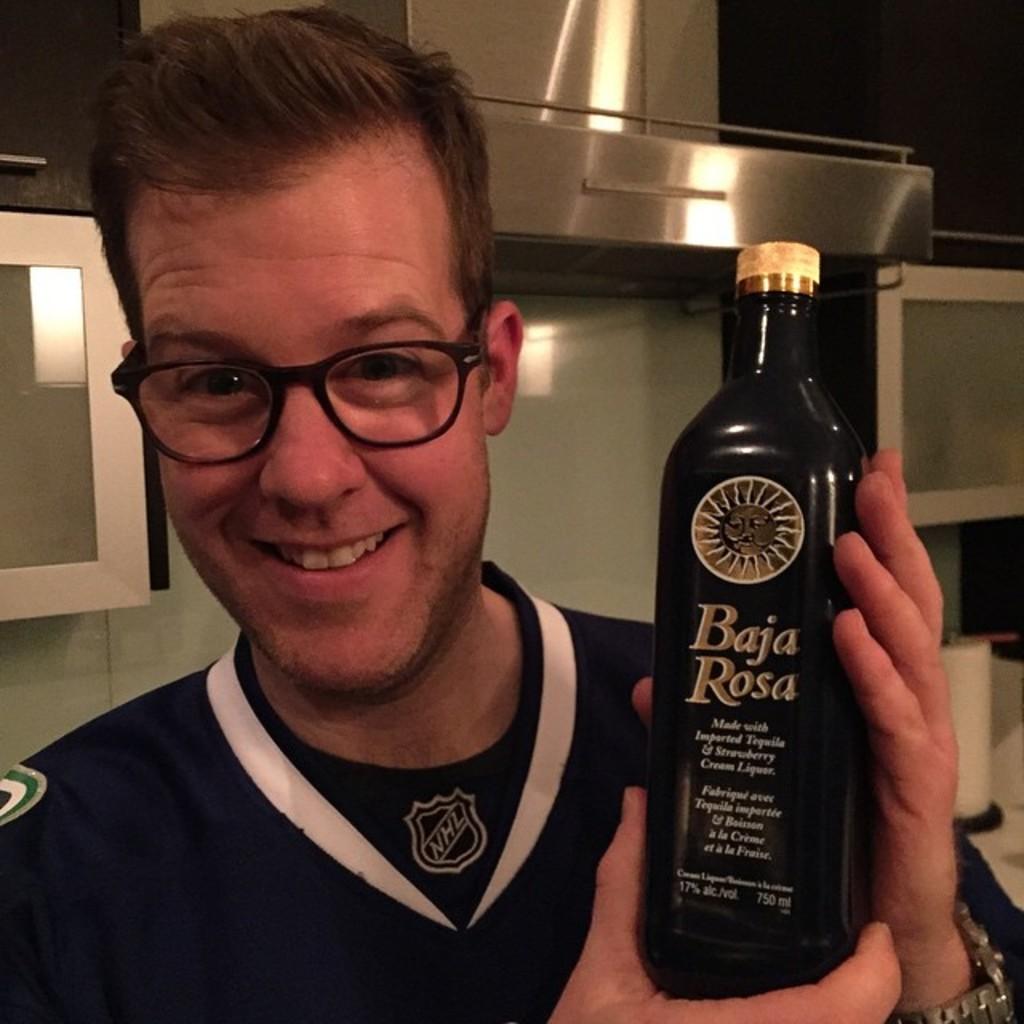What kind of beverage is baja rosa?
Make the answer very short. Unanswerable. How many milliliters is this bottle?
Offer a terse response. 750. 